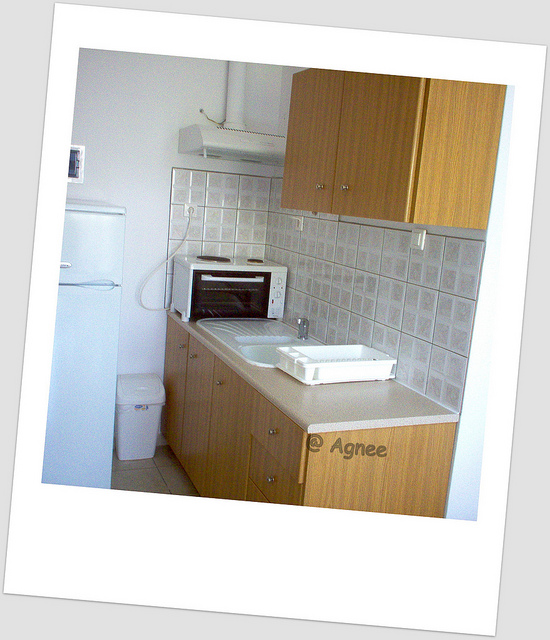<image>What type of air conditioner is there? There is no air conditioner in the image. However, it can possibly be central or portable. What type of air conditioner is there? There is no air conditioner in the image. 